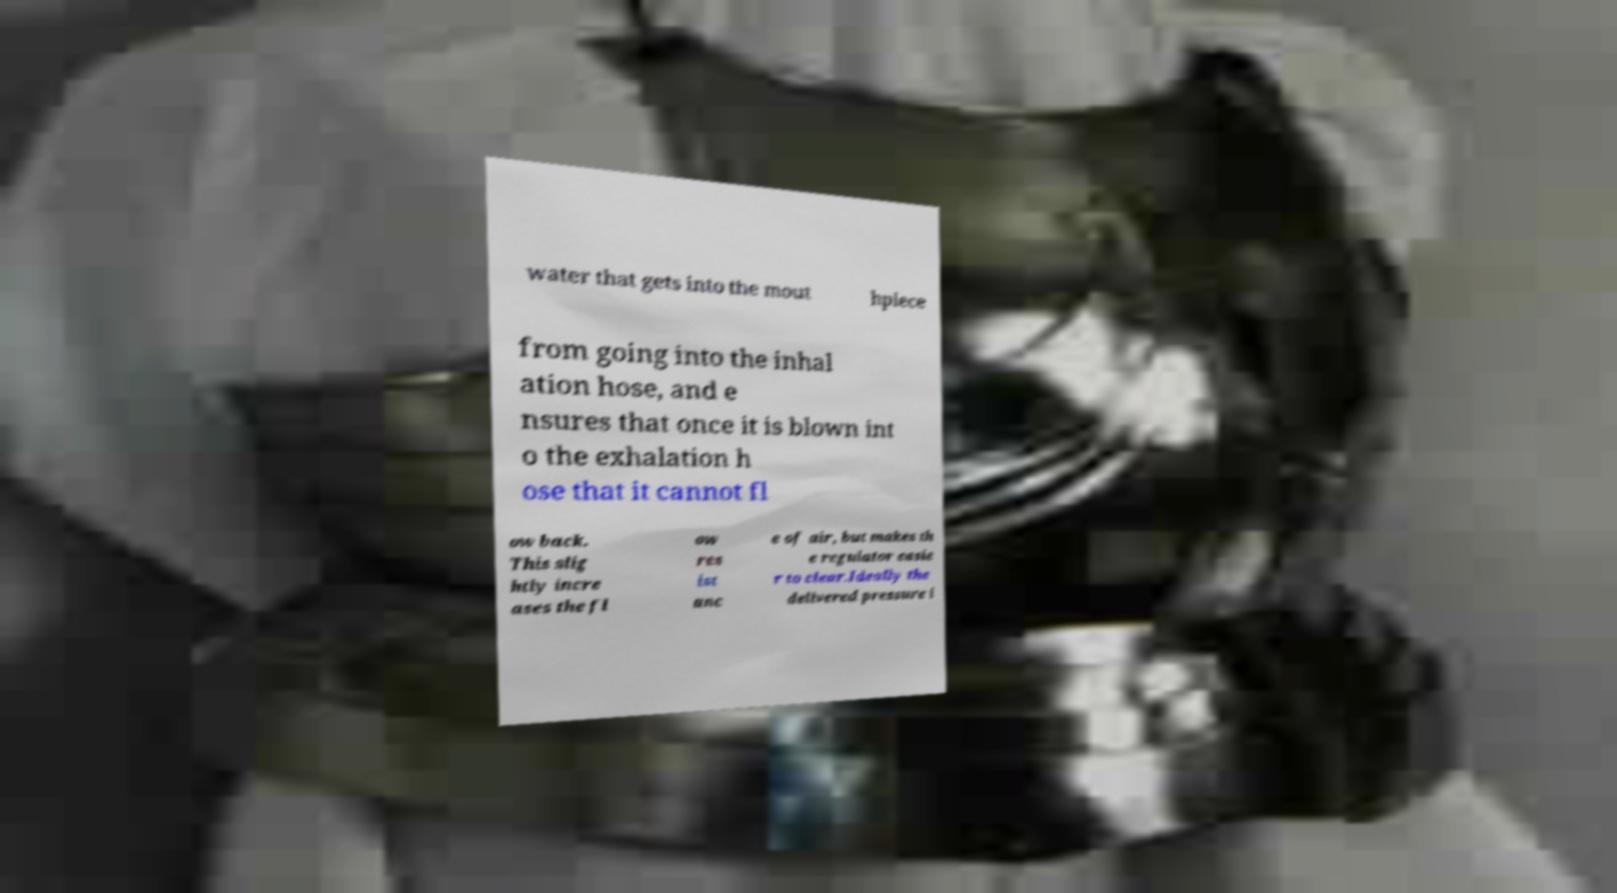Could you extract and type out the text from this image? water that gets into the mout hpiece from going into the inhal ation hose, and e nsures that once it is blown int o the exhalation h ose that it cannot fl ow back. This slig htly incre ases the fl ow res ist anc e of air, but makes th e regulator easie r to clear.Ideally the delivered pressure i 